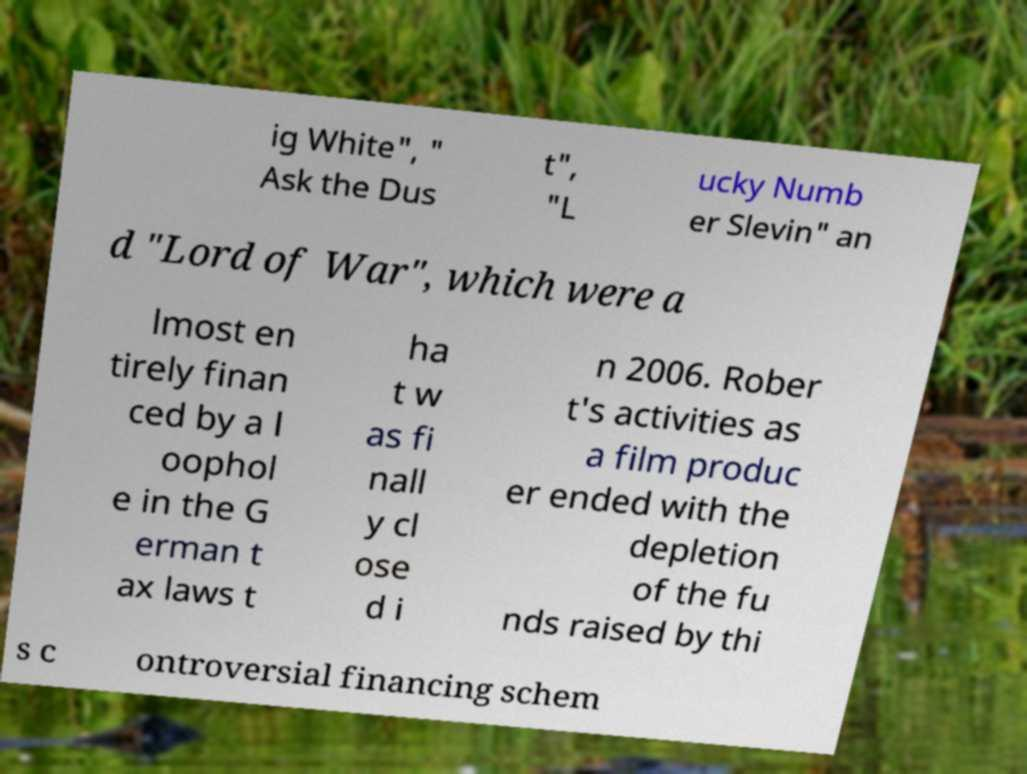Please identify and transcribe the text found in this image. ig White", " Ask the Dus t", "L ucky Numb er Slevin" an d "Lord of War", which were a lmost en tirely finan ced by a l oophol e in the G erman t ax laws t ha t w as fi nall y cl ose d i n 2006. Rober t's activities as a film produc er ended with the depletion of the fu nds raised by thi s c ontroversial financing schem 